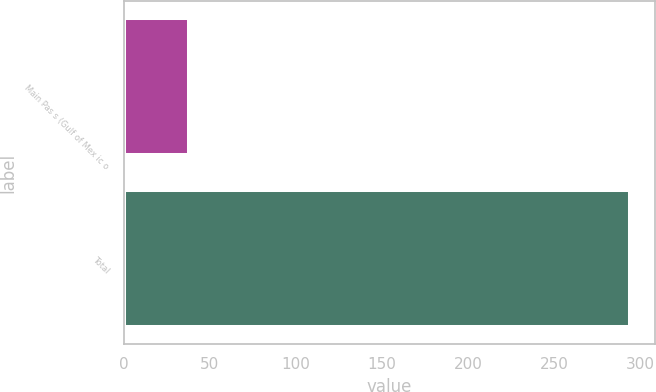Convert chart to OTSL. <chart><loc_0><loc_0><loc_500><loc_500><bar_chart><fcel>Main Pas s (Gulf of Mex ic o<fcel>Total<nl><fcel>38<fcel>294<nl></chart> 